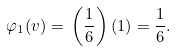<formula> <loc_0><loc_0><loc_500><loc_500>\varphi _ { 1 } ( v ) = \, \left ( { \frac { 1 } { 6 } } \right ) ( 1 ) = { \frac { 1 } { 6 } } .</formula> 